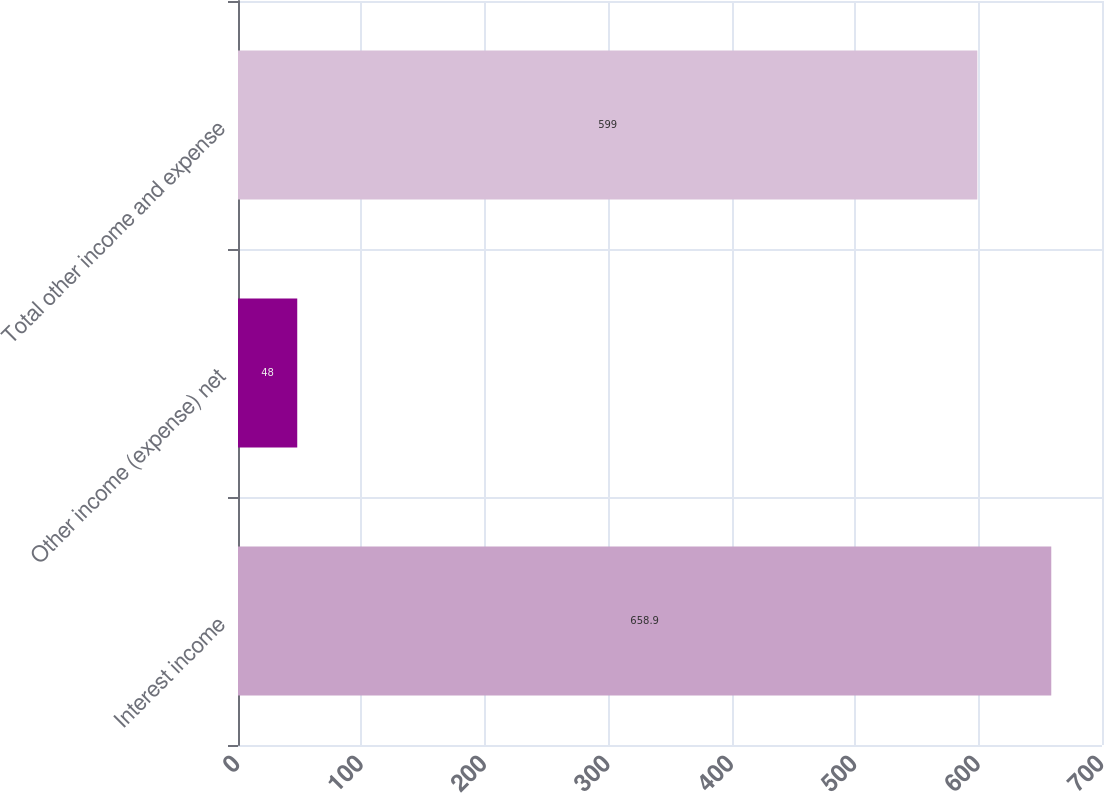Convert chart to OTSL. <chart><loc_0><loc_0><loc_500><loc_500><bar_chart><fcel>Interest income<fcel>Other income (expense) net<fcel>Total other income and expense<nl><fcel>658.9<fcel>48<fcel>599<nl></chart> 